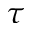<formula> <loc_0><loc_0><loc_500><loc_500>\tau</formula> 